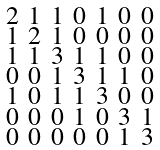<formula> <loc_0><loc_0><loc_500><loc_500>\begin{smallmatrix} 2 & 1 & 1 & 0 & 1 & 0 & 0 \\ 1 & 2 & 1 & 0 & 0 & 0 & 0 \\ 1 & 1 & 3 & 1 & 1 & 0 & 0 \\ 0 & 0 & 1 & 3 & 1 & 1 & 0 \\ 1 & 0 & 1 & 1 & 3 & 0 & 0 \\ 0 & 0 & 0 & 1 & 0 & 3 & 1 \\ 0 & 0 & 0 & 0 & 0 & 1 & 3 \end{smallmatrix}</formula> 